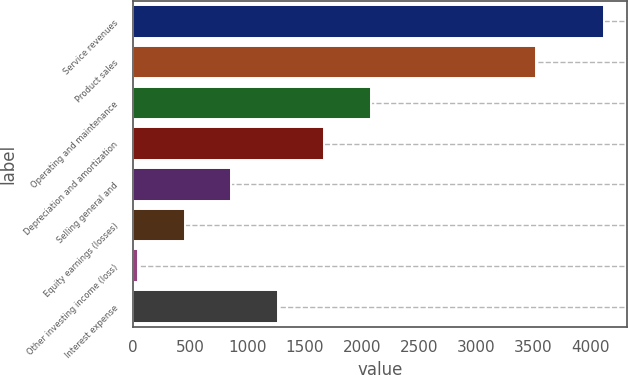Convert chart to OTSL. <chart><loc_0><loc_0><loc_500><loc_500><bar_chart><fcel>Service revenues<fcel>Product sales<fcel>Operating and maintenance<fcel>Depreciation and amortization<fcel>Selling general and<fcel>Equity earnings (losses)<fcel>Other investing income (loss)<fcel>Interest expense<nl><fcel>4116<fcel>3521<fcel>2079.5<fcel>1672.2<fcel>857.6<fcel>450.3<fcel>43<fcel>1264.9<nl></chart> 